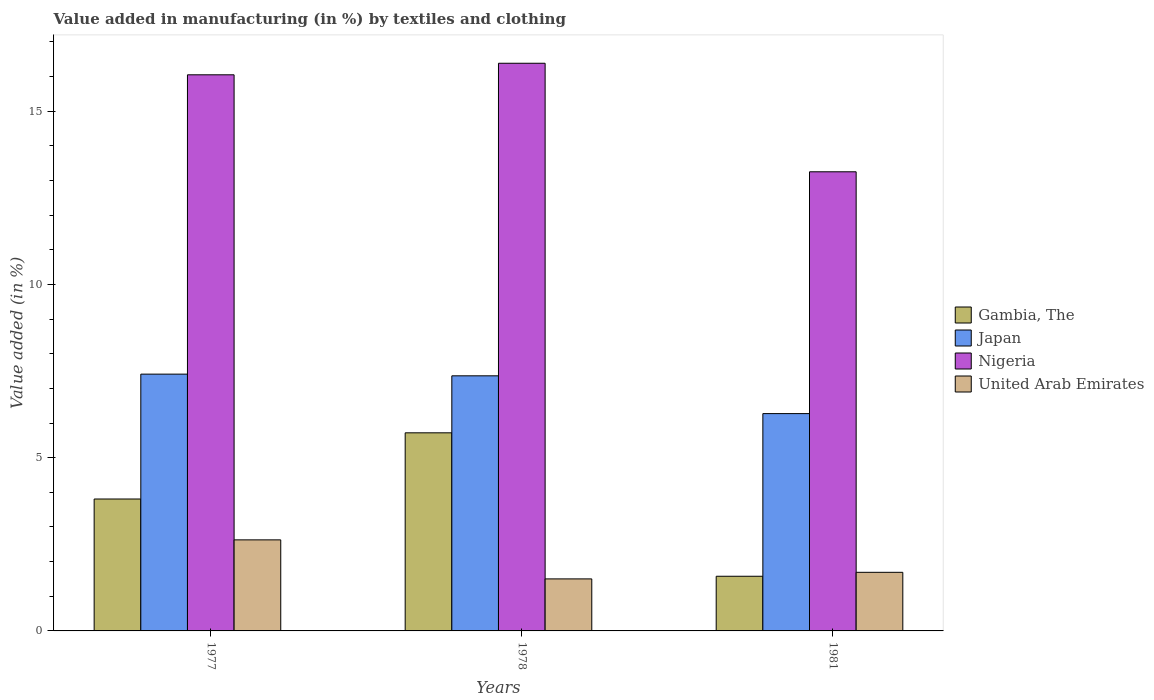How many different coloured bars are there?
Keep it short and to the point. 4. How many groups of bars are there?
Provide a succinct answer. 3. Are the number of bars on each tick of the X-axis equal?
Your answer should be compact. Yes. What is the percentage of value added in manufacturing by textiles and clothing in United Arab Emirates in 1981?
Provide a succinct answer. 1.69. Across all years, what is the maximum percentage of value added in manufacturing by textiles and clothing in United Arab Emirates?
Your answer should be very brief. 2.63. Across all years, what is the minimum percentage of value added in manufacturing by textiles and clothing in United Arab Emirates?
Provide a short and direct response. 1.5. In which year was the percentage of value added in manufacturing by textiles and clothing in Nigeria maximum?
Ensure brevity in your answer.  1978. In which year was the percentage of value added in manufacturing by textiles and clothing in United Arab Emirates minimum?
Your answer should be very brief. 1978. What is the total percentage of value added in manufacturing by textiles and clothing in United Arab Emirates in the graph?
Offer a terse response. 5.82. What is the difference between the percentage of value added in manufacturing by textiles and clothing in Nigeria in 1977 and that in 1981?
Your response must be concise. 2.8. What is the difference between the percentage of value added in manufacturing by textiles and clothing in Japan in 1977 and the percentage of value added in manufacturing by textiles and clothing in United Arab Emirates in 1978?
Offer a very short reply. 5.91. What is the average percentage of value added in manufacturing by textiles and clothing in Nigeria per year?
Ensure brevity in your answer.  15.23. In the year 1981, what is the difference between the percentage of value added in manufacturing by textiles and clothing in Japan and percentage of value added in manufacturing by textiles and clothing in Nigeria?
Keep it short and to the point. -6.98. In how many years, is the percentage of value added in manufacturing by textiles and clothing in Japan greater than 2 %?
Give a very brief answer. 3. What is the ratio of the percentage of value added in manufacturing by textiles and clothing in Nigeria in 1977 to that in 1978?
Your response must be concise. 0.98. Is the percentage of value added in manufacturing by textiles and clothing in Gambia, The in 1977 less than that in 1981?
Ensure brevity in your answer.  No. Is the difference between the percentage of value added in manufacturing by textiles and clothing in Japan in 1977 and 1978 greater than the difference between the percentage of value added in manufacturing by textiles and clothing in Nigeria in 1977 and 1978?
Provide a succinct answer. Yes. What is the difference between the highest and the second highest percentage of value added in manufacturing by textiles and clothing in United Arab Emirates?
Provide a short and direct response. 0.94. What is the difference between the highest and the lowest percentage of value added in manufacturing by textiles and clothing in Nigeria?
Offer a very short reply. 3.13. Is the sum of the percentage of value added in manufacturing by textiles and clothing in Nigeria in 1978 and 1981 greater than the maximum percentage of value added in manufacturing by textiles and clothing in Japan across all years?
Provide a short and direct response. Yes. Is it the case that in every year, the sum of the percentage of value added in manufacturing by textiles and clothing in United Arab Emirates and percentage of value added in manufacturing by textiles and clothing in Gambia, The is greater than the sum of percentage of value added in manufacturing by textiles and clothing in Japan and percentage of value added in manufacturing by textiles and clothing in Nigeria?
Your answer should be compact. No. What does the 4th bar from the left in 1978 represents?
Make the answer very short. United Arab Emirates. What does the 1st bar from the right in 1981 represents?
Your response must be concise. United Arab Emirates. Is it the case that in every year, the sum of the percentage of value added in manufacturing by textiles and clothing in Japan and percentage of value added in manufacturing by textiles and clothing in United Arab Emirates is greater than the percentage of value added in manufacturing by textiles and clothing in Nigeria?
Keep it short and to the point. No. Are all the bars in the graph horizontal?
Offer a very short reply. No. What is the difference between two consecutive major ticks on the Y-axis?
Your answer should be very brief. 5. Are the values on the major ticks of Y-axis written in scientific E-notation?
Give a very brief answer. No. How many legend labels are there?
Provide a succinct answer. 4. What is the title of the graph?
Offer a terse response. Value added in manufacturing (in %) by textiles and clothing. Does "Sweden" appear as one of the legend labels in the graph?
Provide a succinct answer. No. What is the label or title of the Y-axis?
Offer a terse response. Value added (in %). What is the Value added (in %) in Gambia, The in 1977?
Offer a terse response. 3.81. What is the Value added (in %) of Japan in 1977?
Your answer should be compact. 7.41. What is the Value added (in %) in Nigeria in 1977?
Ensure brevity in your answer.  16.05. What is the Value added (in %) of United Arab Emirates in 1977?
Provide a short and direct response. 2.63. What is the Value added (in %) of Gambia, The in 1978?
Provide a short and direct response. 5.72. What is the Value added (in %) of Japan in 1978?
Ensure brevity in your answer.  7.36. What is the Value added (in %) in Nigeria in 1978?
Give a very brief answer. 16.39. What is the Value added (in %) of United Arab Emirates in 1978?
Your response must be concise. 1.5. What is the Value added (in %) in Gambia, The in 1981?
Ensure brevity in your answer.  1.58. What is the Value added (in %) of Japan in 1981?
Provide a succinct answer. 6.27. What is the Value added (in %) of Nigeria in 1981?
Keep it short and to the point. 13.25. What is the Value added (in %) in United Arab Emirates in 1981?
Your answer should be very brief. 1.69. Across all years, what is the maximum Value added (in %) of Gambia, The?
Provide a succinct answer. 5.72. Across all years, what is the maximum Value added (in %) of Japan?
Ensure brevity in your answer.  7.41. Across all years, what is the maximum Value added (in %) in Nigeria?
Provide a short and direct response. 16.39. Across all years, what is the maximum Value added (in %) in United Arab Emirates?
Your answer should be very brief. 2.63. Across all years, what is the minimum Value added (in %) of Gambia, The?
Offer a very short reply. 1.58. Across all years, what is the minimum Value added (in %) in Japan?
Your response must be concise. 6.27. Across all years, what is the minimum Value added (in %) in Nigeria?
Ensure brevity in your answer.  13.25. Across all years, what is the minimum Value added (in %) of United Arab Emirates?
Your response must be concise. 1.5. What is the total Value added (in %) of Gambia, The in the graph?
Offer a very short reply. 11.1. What is the total Value added (in %) in Japan in the graph?
Ensure brevity in your answer.  21.05. What is the total Value added (in %) in Nigeria in the graph?
Offer a very short reply. 45.69. What is the total Value added (in %) of United Arab Emirates in the graph?
Provide a succinct answer. 5.82. What is the difference between the Value added (in %) of Gambia, The in 1977 and that in 1978?
Provide a succinct answer. -1.91. What is the difference between the Value added (in %) in Japan in 1977 and that in 1978?
Provide a short and direct response. 0.05. What is the difference between the Value added (in %) of Nigeria in 1977 and that in 1978?
Your answer should be compact. -0.33. What is the difference between the Value added (in %) in United Arab Emirates in 1977 and that in 1978?
Ensure brevity in your answer.  1.13. What is the difference between the Value added (in %) of Gambia, The in 1977 and that in 1981?
Provide a succinct answer. 2.23. What is the difference between the Value added (in %) of Japan in 1977 and that in 1981?
Your response must be concise. 1.14. What is the difference between the Value added (in %) of Nigeria in 1977 and that in 1981?
Ensure brevity in your answer.  2.8. What is the difference between the Value added (in %) of United Arab Emirates in 1977 and that in 1981?
Ensure brevity in your answer.  0.94. What is the difference between the Value added (in %) in Gambia, The in 1978 and that in 1981?
Your response must be concise. 4.14. What is the difference between the Value added (in %) in Japan in 1978 and that in 1981?
Make the answer very short. 1.09. What is the difference between the Value added (in %) in Nigeria in 1978 and that in 1981?
Offer a terse response. 3.13. What is the difference between the Value added (in %) of United Arab Emirates in 1978 and that in 1981?
Your response must be concise. -0.19. What is the difference between the Value added (in %) of Gambia, The in 1977 and the Value added (in %) of Japan in 1978?
Make the answer very short. -3.56. What is the difference between the Value added (in %) in Gambia, The in 1977 and the Value added (in %) in Nigeria in 1978?
Provide a succinct answer. -12.58. What is the difference between the Value added (in %) in Gambia, The in 1977 and the Value added (in %) in United Arab Emirates in 1978?
Make the answer very short. 2.31. What is the difference between the Value added (in %) of Japan in 1977 and the Value added (in %) of Nigeria in 1978?
Your response must be concise. -8.97. What is the difference between the Value added (in %) of Japan in 1977 and the Value added (in %) of United Arab Emirates in 1978?
Provide a succinct answer. 5.91. What is the difference between the Value added (in %) in Nigeria in 1977 and the Value added (in %) in United Arab Emirates in 1978?
Offer a terse response. 14.55. What is the difference between the Value added (in %) in Gambia, The in 1977 and the Value added (in %) in Japan in 1981?
Offer a terse response. -2.47. What is the difference between the Value added (in %) of Gambia, The in 1977 and the Value added (in %) of Nigeria in 1981?
Offer a very short reply. -9.45. What is the difference between the Value added (in %) of Gambia, The in 1977 and the Value added (in %) of United Arab Emirates in 1981?
Your answer should be very brief. 2.12. What is the difference between the Value added (in %) in Japan in 1977 and the Value added (in %) in Nigeria in 1981?
Provide a short and direct response. -5.84. What is the difference between the Value added (in %) in Japan in 1977 and the Value added (in %) in United Arab Emirates in 1981?
Keep it short and to the point. 5.72. What is the difference between the Value added (in %) of Nigeria in 1977 and the Value added (in %) of United Arab Emirates in 1981?
Provide a short and direct response. 14.36. What is the difference between the Value added (in %) in Gambia, The in 1978 and the Value added (in %) in Japan in 1981?
Give a very brief answer. -0.55. What is the difference between the Value added (in %) in Gambia, The in 1978 and the Value added (in %) in Nigeria in 1981?
Offer a terse response. -7.53. What is the difference between the Value added (in %) of Gambia, The in 1978 and the Value added (in %) of United Arab Emirates in 1981?
Make the answer very short. 4.03. What is the difference between the Value added (in %) in Japan in 1978 and the Value added (in %) in Nigeria in 1981?
Offer a very short reply. -5.89. What is the difference between the Value added (in %) in Japan in 1978 and the Value added (in %) in United Arab Emirates in 1981?
Give a very brief answer. 5.67. What is the difference between the Value added (in %) in Nigeria in 1978 and the Value added (in %) in United Arab Emirates in 1981?
Provide a short and direct response. 14.69. What is the average Value added (in %) of Gambia, The per year?
Ensure brevity in your answer.  3.7. What is the average Value added (in %) of Japan per year?
Your answer should be very brief. 7.02. What is the average Value added (in %) in Nigeria per year?
Keep it short and to the point. 15.23. What is the average Value added (in %) in United Arab Emirates per year?
Give a very brief answer. 1.94. In the year 1977, what is the difference between the Value added (in %) in Gambia, The and Value added (in %) in Japan?
Provide a short and direct response. -3.6. In the year 1977, what is the difference between the Value added (in %) of Gambia, The and Value added (in %) of Nigeria?
Offer a very short reply. -12.24. In the year 1977, what is the difference between the Value added (in %) in Gambia, The and Value added (in %) in United Arab Emirates?
Offer a terse response. 1.18. In the year 1977, what is the difference between the Value added (in %) in Japan and Value added (in %) in Nigeria?
Your response must be concise. -8.64. In the year 1977, what is the difference between the Value added (in %) in Japan and Value added (in %) in United Arab Emirates?
Your answer should be compact. 4.78. In the year 1977, what is the difference between the Value added (in %) in Nigeria and Value added (in %) in United Arab Emirates?
Give a very brief answer. 13.42. In the year 1978, what is the difference between the Value added (in %) of Gambia, The and Value added (in %) of Japan?
Ensure brevity in your answer.  -1.64. In the year 1978, what is the difference between the Value added (in %) in Gambia, The and Value added (in %) in Nigeria?
Offer a very short reply. -10.67. In the year 1978, what is the difference between the Value added (in %) of Gambia, The and Value added (in %) of United Arab Emirates?
Make the answer very short. 4.22. In the year 1978, what is the difference between the Value added (in %) in Japan and Value added (in %) in Nigeria?
Your response must be concise. -9.02. In the year 1978, what is the difference between the Value added (in %) in Japan and Value added (in %) in United Arab Emirates?
Keep it short and to the point. 5.86. In the year 1978, what is the difference between the Value added (in %) in Nigeria and Value added (in %) in United Arab Emirates?
Offer a terse response. 14.88. In the year 1981, what is the difference between the Value added (in %) in Gambia, The and Value added (in %) in Japan?
Your answer should be compact. -4.7. In the year 1981, what is the difference between the Value added (in %) in Gambia, The and Value added (in %) in Nigeria?
Your answer should be very brief. -11.68. In the year 1981, what is the difference between the Value added (in %) in Gambia, The and Value added (in %) in United Arab Emirates?
Your answer should be very brief. -0.11. In the year 1981, what is the difference between the Value added (in %) in Japan and Value added (in %) in Nigeria?
Make the answer very short. -6.98. In the year 1981, what is the difference between the Value added (in %) in Japan and Value added (in %) in United Arab Emirates?
Offer a terse response. 4.58. In the year 1981, what is the difference between the Value added (in %) in Nigeria and Value added (in %) in United Arab Emirates?
Provide a succinct answer. 11.56. What is the ratio of the Value added (in %) of Gambia, The in 1977 to that in 1978?
Ensure brevity in your answer.  0.67. What is the ratio of the Value added (in %) of Japan in 1977 to that in 1978?
Make the answer very short. 1.01. What is the ratio of the Value added (in %) in Nigeria in 1977 to that in 1978?
Give a very brief answer. 0.98. What is the ratio of the Value added (in %) in United Arab Emirates in 1977 to that in 1978?
Give a very brief answer. 1.75. What is the ratio of the Value added (in %) of Gambia, The in 1977 to that in 1981?
Offer a very short reply. 2.41. What is the ratio of the Value added (in %) in Japan in 1977 to that in 1981?
Provide a succinct answer. 1.18. What is the ratio of the Value added (in %) in Nigeria in 1977 to that in 1981?
Provide a short and direct response. 1.21. What is the ratio of the Value added (in %) of United Arab Emirates in 1977 to that in 1981?
Your answer should be compact. 1.55. What is the ratio of the Value added (in %) in Gambia, The in 1978 to that in 1981?
Keep it short and to the point. 3.62. What is the ratio of the Value added (in %) of Japan in 1978 to that in 1981?
Your answer should be compact. 1.17. What is the ratio of the Value added (in %) of Nigeria in 1978 to that in 1981?
Keep it short and to the point. 1.24. What is the ratio of the Value added (in %) of United Arab Emirates in 1978 to that in 1981?
Your response must be concise. 0.89. What is the difference between the highest and the second highest Value added (in %) of Gambia, The?
Your response must be concise. 1.91. What is the difference between the highest and the second highest Value added (in %) of Japan?
Keep it short and to the point. 0.05. What is the difference between the highest and the second highest Value added (in %) in Nigeria?
Offer a very short reply. 0.33. What is the difference between the highest and the second highest Value added (in %) in United Arab Emirates?
Ensure brevity in your answer.  0.94. What is the difference between the highest and the lowest Value added (in %) of Gambia, The?
Give a very brief answer. 4.14. What is the difference between the highest and the lowest Value added (in %) in Japan?
Give a very brief answer. 1.14. What is the difference between the highest and the lowest Value added (in %) in Nigeria?
Provide a succinct answer. 3.13. What is the difference between the highest and the lowest Value added (in %) in United Arab Emirates?
Provide a succinct answer. 1.13. 